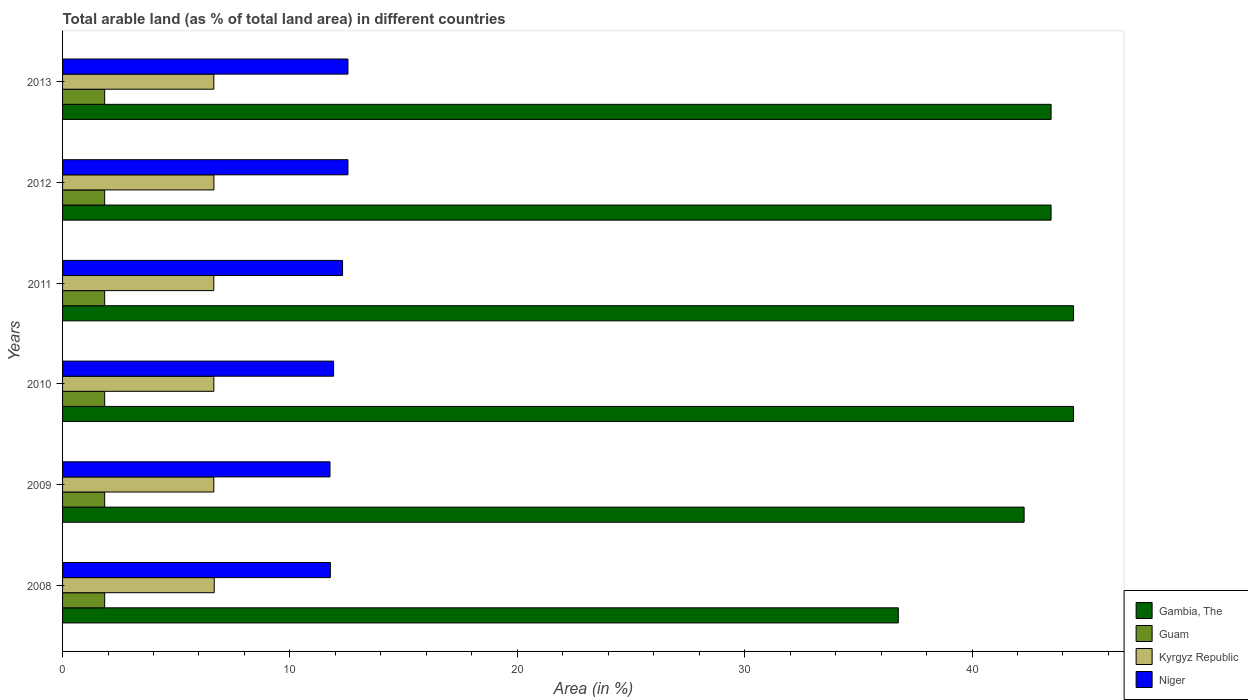How many different coloured bars are there?
Your answer should be very brief. 4. Are the number of bars on each tick of the Y-axis equal?
Offer a terse response. Yes. How many bars are there on the 6th tick from the top?
Offer a terse response. 4. In how many cases, is the number of bars for a given year not equal to the number of legend labels?
Ensure brevity in your answer.  0. What is the percentage of arable land in Gambia, The in 2008?
Keep it short and to the point. 36.76. Across all years, what is the maximum percentage of arable land in Niger?
Make the answer very short. 12.55. Across all years, what is the minimum percentage of arable land in Kyrgyz Republic?
Your response must be concise. 6.65. In which year was the percentage of arable land in Guam minimum?
Provide a short and direct response. 2008. What is the total percentage of arable land in Kyrgyz Republic in the graph?
Ensure brevity in your answer.  39.94. What is the difference between the percentage of arable land in Gambia, The in 2008 and that in 2010?
Offer a very short reply. -7.71. What is the difference between the percentage of arable land in Kyrgyz Republic in 2008 and the percentage of arable land in Niger in 2013?
Offer a terse response. -5.88. What is the average percentage of arable land in Kyrgyz Republic per year?
Provide a short and direct response. 6.66. In the year 2013, what is the difference between the percentage of arable land in Guam and percentage of arable land in Kyrgyz Republic?
Provide a short and direct response. -4.8. In how many years, is the percentage of arable land in Niger greater than 32 %?
Your answer should be compact. 0. What is the ratio of the percentage of arable land in Gambia, The in 2009 to that in 2011?
Your answer should be very brief. 0.95. Is the percentage of arable land in Niger in 2010 less than that in 2011?
Give a very brief answer. Yes. What is the difference between the highest and the second highest percentage of arable land in Kyrgyz Republic?
Ensure brevity in your answer.  0.02. What is the difference between the highest and the lowest percentage of arable land in Kyrgyz Republic?
Make the answer very short. 0.02. In how many years, is the percentage of arable land in Niger greater than the average percentage of arable land in Niger taken over all years?
Offer a very short reply. 3. What does the 4th bar from the top in 2009 represents?
Provide a short and direct response. Gambia, The. What does the 4th bar from the bottom in 2008 represents?
Your response must be concise. Niger. How many years are there in the graph?
Provide a succinct answer. 6. What is the difference between two consecutive major ticks on the X-axis?
Give a very brief answer. 10. Does the graph contain any zero values?
Provide a short and direct response. No. Does the graph contain grids?
Provide a succinct answer. No. How many legend labels are there?
Give a very brief answer. 4. How are the legend labels stacked?
Your answer should be compact. Vertical. What is the title of the graph?
Your response must be concise. Total arable land (as % of total land area) in different countries. What is the label or title of the X-axis?
Offer a very short reply. Area (in %). What is the label or title of the Y-axis?
Offer a very short reply. Years. What is the Area (in %) of Gambia, The in 2008?
Your answer should be very brief. 36.76. What is the Area (in %) in Guam in 2008?
Your answer should be very brief. 1.85. What is the Area (in %) of Kyrgyz Republic in 2008?
Provide a succinct answer. 6.67. What is the Area (in %) of Niger in 2008?
Keep it short and to the point. 11.78. What is the Area (in %) of Gambia, The in 2009?
Make the answer very short. 42.29. What is the Area (in %) in Guam in 2009?
Ensure brevity in your answer.  1.85. What is the Area (in %) in Kyrgyz Republic in 2009?
Your answer should be compact. 6.65. What is the Area (in %) of Niger in 2009?
Offer a very short reply. 11.76. What is the Area (in %) of Gambia, The in 2010?
Keep it short and to the point. 44.47. What is the Area (in %) of Guam in 2010?
Provide a succinct answer. 1.85. What is the Area (in %) in Kyrgyz Republic in 2010?
Your response must be concise. 6.65. What is the Area (in %) of Niger in 2010?
Ensure brevity in your answer.  11.92. What is the Area (in %) in Gambia, The in 2011?
Your response must be concise. 44.47. What is the Area (in %) in Guam in 2011?
Your answer should be very brief. 1.85. What is the Area (in %) in Kyrgyz Republic in 2011?
Offer a very short reply. 6.65. What is the Area (in %) in Niger in 2011?
Your answer should be very brief. 12.32. What is the Area (in %) in Gambia, The in 2012?
Your answer should be very brief. 43.48. What is the Area (in %) in Guam in 2012?
Keep it short and to the point. 1.85. What is the Area (in %) of Kyrgyz Republic in 2012?
Your answer should be very brief. 6.66. What is the Area (in %) in Niger in 2012?
Keep it short and to the point. 12.55. What is the Area (in %) in Gambia, The in 2013?
Your response must be concise. 43.48. What is the Area (in %) of Guam in 2013?
Your response must be concise. 1.85. What is the Area (in %) of Kyrgyz Republic in 2013?
Keep it short and to the point. 6.65. What is the Area (in %) of Niger in 2013?
Provide a short and direct response. 12.55. Across all years, what is the maximum Area (in %) of Gambia, The?
Provide a short and direct response. 44.47. Across all years, what is the maximum Area (in %) in Guam?
Your response must be concise. 1.85. Across all years, what is the maximum Area (in %) in Kyrgyz Republic?
Provide a short and direct response. 6.67. Across all years, what is the maximum Area (in %) in Niger?
Your answer should be very brief. 12.55. Across all years, what is the minimum Area (in %) in Gambia, The?
Your answer should be very brief. 36.76. Across all years, what is the minimum Area (in %) of Guam?
Provide a short and direct response. 1.85. Across all years, what is the minimum Area (in %) of Kyrgyz Republic?
Your response must be concise. 6.65. Across all years, what is the minimum Area (in %) of Niger?
Your answer should be compact. 11.76. What is the total Area (in %) of Gambia, The in the graph?
Give a very brief answer. 254.94. What is the total Area (in %) in Guam in the graph?
Provide a succinct answer. 11.11. What is the total Area (in %) of Kyrgyz Republic in the graph?
Your answer should be compact. 39.94. What is the total Area (in %) in Niger in the graph?
Keep it short and to the point. 72.88. What is the difference between the Area (in %) of Gambia, The in 2008 and that in 2009?
Keep it short and to the point. -5.53. What is the difference between the Area (in %) in Guam in 2008 and that in 2009?
Offer a terse response. 0. What is the difference between the Area (in %) of Kyrgyz Republic in 2008 and that in 2009?
Offer a terse response. 0.02. What is the difference between the Area (in %) in Niger in 2008 and that in 2009?
Your answer should be very brief. 0.02. What is the difference between the Area (in %) in Gambia, The in 2008 and that in 2010?
Your answer should be very brief. -7.71. What is the difference between the Area (in %) in Kyrgyz Republic in 2008 and that in 2010?
Provide a succinct answer. 0.02. What is the difference between the Area (in %) of Niger in 2008 and that in 2010?
Offer a very short reply. -0.14. What is the difference between the Area (in %) of Gambia, The in 2008 and that in 2011?
Your response must be concise. -7.71. What is the difference between the Area (in %) in Guam in 2008 and that in 2011?
Your response must be concise. 0. What is the difference between the Area (in %) of Kyrgyz Republic in 2008 and that in 2011?
Provide a short and direct response. 0.02. What is the difference between the Area (in %) of Niger in 2008 and that in 2011?
Give a very brief answer. -0.54. What is the difference between the Area (in %) of Gambia, The in 2008 and that in 2012?
Make the answer very short. -6.72. What is the difference between the Area (in %) of Kyrgyz Republic in 2008 and that in 2012?
Provide a succinct answer. 0.02. What is the difference between the Area (in %) of Niger in 2008 and that in 2012?
Provide a short and direct response. -0.77. What is the difference between the Area (in %) in Gambia, The in 2008 and that in 2013?
Your answer should be very brief. -6.72. What is the difference between the Area (in %) of Guam in 2008 and that in 2013?
Provide a short and direct response. 0. What is the difference between the Area (in %) of Kyrgyz Republic in 2008 and that in 2013?
Your answer should be compact. 0.02. What is the difference between the Area (in %) of Niger in 2008 and that in 2013?
Provide a short and direct response. -0.77. What is the difference between the Area (in %) in Gambia, The in 2009 and that in 2010?
Ensure brevity in your answer.  -2.17. What is the difference between the Area (in %) of Guam in 2009 and that in 2010?
Provide a succinct answer. 0. What is the difference between the Area (in %) in Kyrgyz Republic in 2009 and that in 2010?
Ensure brevity in your answer.  -0. What is the difference between the Area (in %) of Niger in 2009 and that in 2010?
Provide a short and direct response. -0.16. What is the difference between the Area (in %) in Gambia, The in 2009 and that in 2011?
Provide a short and direct response. -2.17. What is the difference between the Area (in %) in Guam in 2009 and that in 2011?
Make the answer very short. 0. What is the difference between the Area (in %) of Kyrgyz Republic in 2009 and that in 2011?
Keep it short and to the point. 0. What is the difference between the Area (in %) of Niger in 2009 and that in 2011?
Give a very brief answer. -0.55. What is the difference between the Area (in %) in Gambia, The in 2009 and that in 2012?
Provide a succinct answer. -1.19. What is the difference between the Area (in %) in Kyrgyz Republic in 2009 and that in 2012?
Make the answer very short. -0. What is the difference between the Area (in %) of Niger in 2009 and that in 2012?
Give a very brief answer. -0.79. What is the difference between the Area (in %) in Gambia, The in 2009 and that in 2013?
Offer a terse response. -1.19. What is the difference between the Area (in %) in Guam in 2009 and that in 2013?
Your response must be concise. 0. What is the difference between the Area (in %) of Kyrgyz Republic in 2009 and that in 2013?
Keep it short and to the point. 0. What is the difference between the Area (in %) in Niger in 2009 and that in 2013?
Your answer should be compact. -0.79. What is the difference between the Area (in %) of Guam in 2010 and that in 2011?
Make the answer very short. 0. What is the difference between the Area (in %) of Kyrgyz Republic in 2010 and that in 2011?
Your response must be concise. 0. What is the difference between the Area (in %) of Niger in 2010 and that in 2011?
Keep it short and to the point. -0.39. What is the difference between the Area (in %) of Guam in 2010 and that in 2012?
Ensure brevity in your answer.  0. What is the difference between the Area (in %) of Kyrgyz Republic in 2010 and that in 2012?
Ensure brevity in your answer.  -0. What is the difference between the Area (in %) in Niger in 2010 and that in 2012?
Provide a succinct answer. -0.63. What is the difference between the Area (in %) of Gambia, The in 2010 and that in 2013?
Your response must be concise. 0.99. What is the difference between the Area (in %) of Kyrgyz Republic in 2010 and that in 2013?
Provide a short and direct response. 0. What is the difference between the Area (in %) of Niger in 2010 and that in 2013?
Provide a short and direct response. -0.63. What is the difference between the Area (in %) of Gambia, The in 2011 and that in 2012?
Keep it short and to the point. 0.99. What is the difference between the Area (in %) of Kyrgyz Republic in 2011 and that in 2012?
Offer a very short reply. -0. What is the difference between the Area (in %) in Niger in 2011 and that in 2012?
Your answer should be very brief. -0.24. What is the difference between the Area (in %) of Gambia, The in 2011 and that in 2013?
Offer a terse response. 0.99. What is the difference between the Area (in %) of Kyrgyz Republic in 2011 and that in 2013?
Your response must be concise. -0. What is the difference between the Area (in %) in Niger in 2011 and that in 2013?
Offer a very short reply. -0.24. What is the difference between the Area (in %) in Gambia, The in 2012 and that in 2013?
Keep it short and to the point. 0. What is the difference between the Area (in %) of Guam in 2012 and that in 2013?
Give a very brief answer. 0. What is the difference between the Area (in %) in Kyrgyz Republic in 2012 and that in 2013?
Ensure brevity in your answer.  0. What is the difference between the Area (in %) in Niger in 2012 and that in 2013?
Ensure brevity in your answer.  0. What is the difference between the Area (in %) of Gambia, The in 2008 and the Area (in %) of Guam in 2009?
Offer a very short reply. 34.91. What is the difference between the Area (in %) in Gambia, The in 2008 and the Area (in %) in Kyrgyz Republic in 2009?
Your answer should be compact. 30.11. What is the difference between the Area (in %) of Gambia, The in 2008 and the Area (in %) of Niger in 2009?
Keep it short and to the point. 25. What is the difference between the Area (in %) in Guam in 2008 and the Area (in %) in Kyrgyz Republic in 2009?
Your answer should be compact. -4.8. What is the difference between the Area (in %) in Guam in 2008 and the Area (in %) in Niger in 2009?
Provide a succinct answer. -9.91. What is the difference between the Area (in %) of Kyrgyz Republic in 2008 and the Area (in %) of Niger in 2009?
Make the answer very short. -5.09. What is the difference between the Area (in %) of Gambia, The in 2008 and the Area (in %) of Guam in 2010?
Offer a terse response. 34.91. What is the difference between the Area (in %) of Gambia, The in 2008 and the Area (in %) of Kyrgyz Republic in 2010?
Your answer should be very brief. 30.11. What is the difference between the Area (in %) of Gambia, The in 2008 and the Area (in %) of Niger in 2010?
Your answer should be very brief. 24.84. What is the difference between the Area (in %) of Guam in 2008 and the Area (in %) of Kyrgyz Republic in 2010?
Give a very brief answer. -4.8. What is the difference between the Area (in %) of Guam in 2008 and the Area (in %) of Niger in 2010?
Provide a short and direct response. -10.07. What is the difference between the Area (in %) of Kyrgyz Republic in 2008 and the Area (in %) of Niger in 2010?
Provide a short and direct response. -5.25. What is the difference between the Area (in %) in Gambia, The in 2008 and the Area (in %) in Guam in 2011?
Keep it short and to the point. 34.91. What is the difference between the Area (in %) of Gambia, The in 2008 and the Area (in %) of Kyrgyz Republic in 2011?
Your response must be concise. 30.11. What is the difference between the Area (in %) in Gambia, The in 2008 and the Area (in %) in Niger in 2011?
Your response must be concise. 24.44. What is the difference between the Area (in %) of Guam in 2008 and the Area (in %) of Kyrgyz Republic in 2011?
Offer a terse response. -4.8. What is the difference between the Area (in %) in Guam in 2008 and the Area (in %) in Niger in 2011?
Make the answer very short. -10.46. What is the difference between the Area (in %) of Kyrgyz Republic in 2008 and the Area (in %) of Niger in 2011?
Ensure brevity in your answer.  -5.64. What is the difference between the Area (in %) of Gambia, The in 2008 and the Area (in %) of Guam in 2012?
Make the answer very short. 34.91. What is the difference between the Area (in %) of Gambia, The in 2008 and the Area (in %) of Kyrgyz Republic in 2012?
Offer a very short reply. 30.1. What is the difference between the Area (in %) in Gambia, The in 2008 and the Area (in %) in Niger in 2012?
Provide a short and direct response. 24.21. What is the difference between the Area (in %) in Guam in 2008 and the Area (in %) in Kyrgyz Republic in 2012?
Your response must be concise. -4.8. What is the difference between the Area (in %) in Guam in 2008 and the Area (in %) in Niger in 2012?
Make the answer very short. -10.7. What is the difference between the Area (in %) in Kyrgyz Republic in 2008 and the Area (in %) in Niger in 2012?
Keep it short and to the point. -5.88. What is the difference between the Area (in %) of Gambia, The in 2008 and the Area (in %) of Guam in 2013?
Give a very brief answer. 34.91. What is the difference between the Area (in %) of Gambia, The in 2008 and the Area (in %) of Kyrgyz Republic in 2013?
Your response must be concise. 30.11. What is the difference between the Area (in %) of Gambia, The in 2008 and the Area (in %) of Niger in 2013?
Provide a short and direct response. 24.21. What is the difference between the Area (in %) in Guam in 2008 and the Area (in %) in Kyrgyz Republic in 2013?
Provide a short and direct response. -4.8. What is the difference between the Area (in %) in Guam in 2008 and the Area (in %) in Niger in 2013?
Ensure brevity in your answer.  -10.7. What is the difference between the Area (in %) in Kyrgyz Republic in 2008 and the Area (in %) in Niger in 2013?
Provide a succinct answer. -5.88. What is the difference between the Area (in %) of Gambia, The in 2009 and the Area (in %) of Guam in 2010?
Keep it short and to the point. 40.44. What is the difference between the Area (in %) in Gambia, The in 2009 and the Area (in %) in Kyrgyz Republic in 2010?
Your answer should be compact. 35.64. What is the difference between the Area (in %) of Gambia, The in 2009 and the Area (in %) of Niger in 2010?
Ensure brevity in your answer.  30.37. What is the difference between the Area (in %) of Guam in 2009 and the Area (in %) of Kyrgyz Republic in 2010?
Give a very brief answer. -4.8. What is the difference between the Area (in %) in Guam in 2009 and the Area (in %) in Niger in 2010?
Offer a very short reply. -10.07. What is the difference between the Area (in %) in Kyrgyz Republic in 2009 and the Area (in %) in Niger in 2010?
Your answer should be very brief. -5.27. What is the difference between the Area (in %) of Gambia, The in 2009 and the Area (in %) of Guam in 2011?
Provide a short and direct response. 40.44. What is the difference between the Area (in %) of Gambia, The in 2009 and the Area (in %) of Kyrgyz Republic in 2011?
Provide a succinct answer. 35.64. What is the difference between the Area (in %) in Gambia, The in 2009 and the Area (in %) in Niger in 2011?
Provide a succinct answer. 29.98. What is the difference between the Area (in %) of Guam in 2009 and the Area (in %) of Kyrgyz Republic in 2011?
Make the answer very short. -4.8. What is the difference between the Area (in %) of Guam in 2009 and the Area (in %) of Niger in 2011?
Ensure brevity in your answer.  -10.46. What is the difference between the Area (in %) of Kyrgyz Republic in 2009 and the Area (in %) of Niger in 2011?
Give a very brief answer. -5.66. What is the difference between the Area (in %) of Gambia, The in 2009 and the Area (in %) of Guam in 2012?
Provide a short and direct response. 40.44. What is the difference between the Area (in %) in Gambia, The in 2009 and the Area (in %) in Kyrgyz Republic in 2012?
Give a very brief answer. 35.64. What is the difference between the Area (in %) of Gambia, The in 2009 and the Area (in %) of Niger in 2012?
Offer a terse response. 29.74. What is the difference between the Area (in %) in Guam in 2009 and the Area (in %) in Kyrgyz Republic in 2012?
Give a very brief answer. -4.8. What is the difference between the Area (in %) in Guam in 2009 and the Area (in %) in Niger in 2012?
Offer a very short reply. -10.7. What is the difference between the Area (in %) in Kyrgyz Republic in 2009 and the Area (in %) in Niger in 2012?
Provide a succinct answer. -5.9. What is the difference between the Area (in %) of Gambia, The in 2009 and the Area (in %) of Guam in 2013?
Give a very brief answer. 40.44. What is the difference between the Area (in %) of Gambia, The in 2009 and the Area (in %) of Kyrgyz Republic in 2013?
Offer a very short reply. 35.64. What is the difference between the Area (in %) in Gambia, The in 2009 and the Area (in %) in Niger in 2013?
Provide a short and direct response. 29.74. What is the difference between the Area (in %) of Guam in 2009 and the Area (in %) of Kyrgyz Republic in 2013?
Keep it short and to the point. -4.8. What is the difference between the Area (in %) in Guam in 2009 and the Area (in %) in Niger in 2013?
Provide a short and direct response. -10.7. What is the difference between the Area (in %) in Kyrgyz Republic in 2009 and the Area (in %) in Niger in 2013?
Provide a short and direct response. -5.9. What is the difference between the Area (in %) of Gambia, The in 2010 and the Area (in %) of Guam in 2011?
Make the answer very short. 42.61. What is the difference between the Area (in %) in Gambia, The in 2010 and the Area (in %) in Kyrgyz Republic in 2011?
Your answer should be very brief. 37.81. What is the difference between the Area (in %) in Gambia, The in 2010 and the Area (in %) in Niger in 2011?
Make the answer very short. 32.15. What is the difference between the Area (in %) in Guam in 2010 and the Area (in %) in Kyrgyz Republic in 2011?
Your response must be concise. -4.8. What is the difference between the Area (in %) in Guam in 2010 and the Area (in %) in Niger in 2011?
Your response must be concise. -10.46. What is the difference between the Area (in %) of Kyrgyz Republic in 2010 and the Area (in %) of Niger in 2011?
Make the answer very short. -5.66. What is the difference between the Area (in %) in Gambia, The in 2010 and the Area (in %) in Guam in 2012?
Keep it short and to the point. 42.61. What is the difference between the Area (in %) of Gambia, The in 2010 and the Area (in %) of Kyrgyz Republic in 2012?
Provide a short and direct response. 37.81. What is the difference between the Area (in %) of Gambia, The in 2010 and the Area (in %) of Niger in 2012?
Offer a very short reply. 31.91. What is the difference between the Area (in %) in Guam in 2010 and the Area (in %) in Kyrgyz Republic in 2012?
Keep it short and to the point. -4.8. What is the difference between the Area (in %) in Guam in 2010 and the Area (in %) in Niger in 2012?
Provide a succinct answer. -10.7. What is the difference between the Area (in %) of Kyrgyz Republic in 2010 and the Area (in %) of Niger in 2012?
Make the answer very short. -5.9. What is the difference between the Area (in %) of Gambia, The in 2010 and the Area (in %) of Guam in 2013?
Make the answer very short. 42.61. What is the difference between the Area (in %) in Gambia, The in 2010 and the Area (in %) in Kyrgyz Republic in 2013?
Ensure brevity in your answer.  37.81. What is the difference between the Area (in %) in Gambia, The in 2010 and the Area (in %) in Niger in 2013?
Keep it short and to the point. 31.91. What is the difference between the Area (in %) in Guam in 2010 and the Area (in %) in Kyrgyz Republic in 2013?
Ensure brevity in your answer.  -4.8. What is the difference between the Area (in %) in Guam in 2010 and the Area (in %) in Niger in 2013?
Ensure brevity in your answer.  -10.7. What is the difference between the Area (in %) of Kyrgyz Republic in 2010 and the Area (in %) of Niger in 2013?
Ensure brevity in your answer.  -5.9. What is the difference between the Area (in %) of Gambia, The in 2011 and the Area (in %) of Guam in 2012?
Provide a succinct answer. 42.61. What is the difference between the Area (in %) in Gambia, The in 2011 and the Area (in %) in Kyrgyz Republic in 2012?
Give a very brief answer. 37.81. What is the difference between the Area (in %) in Gambia, The in 2011 and the Area (in %) in Niger in 2012?
Your answer should be compact. 31.91. What is the difference between the Area (in %) in Guam in 2011 and the Area (in %) in Kyrgyz Republic in 2012?
Provide a short and direct response. -4.8. What is the difference between the Area (in %) in Guam in 2011 and the Area (in %) in Niger in 2012?
Keep it short and to the point. -10.7. What is the difference between the Area (in %) of Kyrgyz Republic in 2011 and the Area (in %) of Niger in 2012?
Offer a terse response. -5.9. What is the difference between the Area (in %) of Gambia, The in 2011 and the Area (in %) of Guam in 2013?
Your answer should be very brief. 42.61. What is the difference between the Area (in %) in Gambia, The in 2011 and the Area (in %) in Kyrgyz Republic in 2013?
Offer a very short reply. 37.81. What is the difference between the Area (in %) of Gambia, The in 2011 and the Area (in %) of Niger in 2013?
Offer a terse response. 31.91. What is the difference between the Area (in %) of Guam in 2011 and the Area (in %) of Kyrgyz Republic in 2013?
Give a very brief answer. -4.8. What is the difference between the Area (in %) of Guam in 2011 and the Area (in %) of Niger in 2013?
Give a very brief answer. -10.7. What is the difference between the Area (in %) of Kyrgyz Republic in 2011 and the Area (in %) of Niger in 2013?
Ensure brevity in your answer.  -5.9. What is the difference between the Area (in %) of Gambia, The in 2012 and the Area (in %) of Guam in 2013?
Provide a short and direct response. 41.63. What is the difference between the Area (in %) in Gambia, The in 2012 and the Area (in %) in Kyrgyz Republic in 2013?
Offer a terse response. 36.83. What is the difference between the Area (in %) in Gambia, The in 2012 and the Area (in %) in Niger in 2013?
Make the answer very short. 30.93. What is the difference between the Area (in %) in Guam in 2012 and the Area (in %) in Kyrgyz Republic in 2013?
Offer a terse response. -4.8. What is the difference between the Area (in %) in Guam in 2012 and the Area (in %) in Niger in 2013?
Provide a succinct answer. -10.7. What is the difference between the Area (in %) in Kyrgyz Republic in 2012 and the Area (in %) in Niger in 2013?
Make the answer very short. -5.9. What is the average Area (in %) of Gambia, The per year?
Give a very brief answer. 42.49. What is the average Area (in %) of Guam per year?
Your answer should be very brief. 1.85. What is the average Area (in %) of Kyrgyz Republic per year?
Provide a short and direct response. 6.66. What is the average Area (in %) of Niger per year?
Provide a short and direct response. 12.15. In the year 2008, what is the difference between the Area (in %) in Gambia, The and Area (in %) in Guam?
Keep it short and to the point. 34.91. In the year 2008, what is the difference between the Area (in %) of Gambia, The and Area (in %) of Kyrgyz Republic?
Give a very brief answer. 30.09. In the year 2008, what is the difference between the Area (in %) of Gambia, The and Area (in %) of Niger?
Provide a short and direct response. 24.98. In the year 2008, what is the difference between the Area (in %) in Guam and Area (in %) in Kyrgyz Republic?
Make the answer very short. -4.82. In the year 2008, what is the difference between the Area (in %) of Guam and Area (in %) of Niger?
Provide a succinct answer. -9.93. In the year 2008, what is the difference between the Area (in %) of Kyrgyz Republic and Area (in %) of Niger?
Make the answer very short. -5.11. In the year 2009, what is the difference between the Area (in %) of Gambia, The and Area (in %) of Guam?
Keep it short and to the point. 40.44. In the year 2009, what is the difference between the Area (in %) of Gambia, The and Area (in %) of Kyrgyz Republic?
Provide a short and direct response. 35.64. In the year 2009, what is the difference between the Area (in %) in Gambia, The and Area (in %) in Niger?
Offer a terse response. 30.53. In the year 2009, what is the difference between the Area (in %) of Guam and Area (in %) of Kyrgyz Republic?
Your answer should be compact. -4.8. In the year 2009, what is the difference between the Area (in %) of Guam and Area (in %) of Niger?
Your response must be concise. -9.91. In the year 2009, what is the difference between the Area (in %) in Kyrgyz Republic and Area (in %) in Niger?
Provide a short and direct response. -5.11. In the year 2010, what is the difference between the Area (in %) in Gambia, The and Area (in %) in Guam?
Provide a short and direct response. 42.61. In the year 2010, what is the difference between the Area (in %) in Gambia, The and Area (in %) in Kyrgyz Republic?
Provide a succinct answer. 37.81. In the year 2010, what is the difference between the Area (in %) of Gambia, The and Area (in %) of Niger?
Keep it short and to the point. 32.55. In the year 2010, what is the difference between the Area (in %) of Guam and Area (in %) of Kyrgyz Republic?
Offer a very short reply. -4.8. In the year 2010, what is the difference between the Area (in %) in Guam and Area (in %) in Niger?
Your answer should be compact. -10.07. In the year 2010, what is the difference between the Area (in %) in Kyrgyz Republic and Area (in %) in Niger?
Your answer should be very brief. -5.27. In the year 2011, what is the difference between the Area (in %) in Gambia, The and Area (in %) in Guam?
Your response must be concise. 42.61. In the year 2011, what is the difference between the Area (in %) of Gambia, The and Area (in %) of Kyrgyz Republic?
Offer a very short reply. 37.81. In the year 2011, what is the difference between the Area (in %) in Gambia, The and Area (in %) in Niger?
Ensure brevity in your answer.  32.15. In the year 2011, what is the difference between the Area (in %) of Guam and Area (in %) of Kyrgyz Republic?
Ensure brevity in your answer.  -4.8. In the year 2011, what is the difference between the Area (in %) of Guam and Area (in %) of Niger?
Offer a terse response. -10.46. In the year 2011, what is the difference between the Area (in %) of Kyrgyz Republic and Area (in %) of Niger?
Provide a short and direct response. -5.66. In the year 2012, what is the difference between the Area (in %) in Gambia, The and Area (in %) in Guam?
Give a very brief answer. 41.63. In the year 2012, what is the difference between the Area (in %) in Gambia, The and Area (in %) in Kyrgyz Republic?
Offer a very short reply. 36.82. In the year 2012, what is the difference between the Area (in %) in Gambia, The and Area (in %) in Niger?
Your response must be concise. 30.93. In the year 2012, what is the difference between the Area (in %) in Guam and Area (in %) in Kyrgyz Republic?
Offer a terse response. -4.8. In the year 2012, what is the difference between the Area (in %) of Guam and Area (in %) of Niger?
Your answer should be compact. -10.7. In the year 2012, what is the difference between the Area (in %) in Kyrgyz Republic and Area (in %) in Niger?
Keep it short and to the point. -5.9. In the year 2013, what is the difference between the Area (in %) in Gambia, The and Area (in %) in Guam?
Provide a succinct answer. 41.63. In the year 2013, what is the difference between the Area (in %) in Gambia, The and Area (in %) in Kyrgyz Republic?
Provide a succinct answer. 36.83. In the year 2013, what is the difference between the Area (in %) of Gambia, The and Area (in %) of Niger?
Offer a terse response. 30.93. In the year 2013, what is the difference between the Area (in %) of Guam and Area (in %) of Kyrgyz Republic?
Provide a short and direct response. -4.8. In the year 2013, what is the difference between the Area (in %) in Guam and Area (in %) in Niger?
Your answer should be compact. -10.7. In the year 2013, what is the difference between the Area (in %) of Kyrgyz Republic and Area (in %) of Niger?
Ensure brevity in your answer.  -5.9. What is the ratio of the Area (in %) of Gambia, The in 2008 to that in 2009?
Offer a terse response. 0.87. What is the ratio of the Area (in %) of Guam in 2008 to that in 2009?
Make the answer very short. 1. What is the ratio of the Area (in %) of Gambia, The in 2008 to that in 2010?
Your answer should be compact. 0.83. What is the ratio of the Area (in %) in Kyrgyz Republic in 2008 to that in 2010?
Your answer should be compact. 1. What is the ratio of the Area (in %) in Niger in 2008 to that in 2010?
Your response must be concise. 0.99. What is the ratio of the Area (in %) of Gambia, The in 2008 to that in 2011?
Offer a terse response. 0.83. What is the ratio of the Area (in %) of Niger in 2008 to that in 2011?
Ensure brevity in your answer.  0.96. What is the ratio of the Area (in %) in Gambia, The in 2008 to that in 2012?
Keep it short and to the point. 0.85. What is the ratio of the Area (in %) of Guam in 2008 to that in 2012?
Your answer should be very brief. 1. What is the ratio of the Area (in %) of Niger in 2008 to that in 2012?
Your answer should be very brief. 0.94. What is the ratio of the Area (in %) in Gambia, The in 2008 to that in 2013?
Give a very brief answer. 0.85. What is the ratio of the Area (in %) of Guam in 2008 to that in 2013?
Ensure brevity in your answer.  1. What is the ratio of the Area (in %) of Kyrgyz Republic in 2008 to that in 2013?
Give a very brief answer. 1. What is the ratio of the Area (in %) in Niger in 2008 to that in 2013?
Keep it short and to the point. 0.94. What is the ratio of the Area (in %) of Gambia, The in 2009 to that in 2010?
Your response must be concise. 0.95. What is the ratio of the Area (in %) of Niger in 2009 to that in 2010?
Provide a succinct answer. 0.99. What is the ratio of the Area (in %) of Gambia, The in 2009 to that in 2011?
Keep it short and to the point. 0.95. What is the ratio of the Area (in %) of Guam in 2009 to that in 2011?
Your answer should be compact. 1. What is the ratio of the Area (in %) of Kyrgyz Republic in 2009 to that in 2011?
Give a very brief answer. 1. What is the ratio of the Area (in %) of Niger in 2009 to that in 2011?
Give a very brief answer. 0.96. What is the ratio of the Area (in %) of Gambia, The in 2009 to that in 2012?
Your answer should be compact. 0.97. What is the ratio of the Area (in %) in Guam in 2009 to that in 2012?
Your answer should be very brief. 1. What is the ratio of the Area (in %) in Kyrgyz Republic in 2009 to that in 2012?
Provide a short and direct response. 1. What is the ratio of the Area (in %) in Niger in 2009 to that in 2012?
Your response must be concise. 0.94. What is the ratio of the Area (in %) in Gambia, The in 2009 to that in 2013?
Your answer should be very brief. 0.97. What is the ratio of the Area (in %) of Guam in 2009 to that in 2013?
Make the answer very short. 1. What is the ratio of the Area (in %) of Kyrgyz Republic in 2009 to that in 2013?
Your answer should be very brief. 1. What is the ratio of the Area (in %) of Niger in 2009 to that in 2013?
Keep it short and to the point. 0.94. What is the ratio of the Area (in %) of Gambia, The in 2010 to that in 2011?
Your answer should be very brief. 1. What is the ratio of the Area (in %) of Guam in 2010 to that in 2011?
Provide a short and direct response. 1. What is the ratio of the Area (in %) of Kyrgyz Republic in 2010 to that in 2011?
Ensure brevity in your answer.  1. What is the ratio of the Area (in %) in Niger in 2010 to that in 2011?
Your answer should be compact. 0.97. What is the ratio of the Area (in %) of Gambia, The in 2010 to that in 2012?
Provide a succinct answer. 1.02. What is the ratio of the Area (in %) in Niger in 2010 to that in 2012?
Make the answer very short. 0.95. What is the ratio of the Area (in %) in Gambia, The in 2010 to that in 2013?
Your answer should be very brief. 1.02. What is the ratio of the Area (in %) of Guam in 2010 to that in 2013?
Ensure brevity in your answer.  1. What is the ratio of the Area (in %) in Kyrgyz Republic in 2010 to that in 2013?
Provide a succinct answer. 1. What is the ratio of the Area (in %) of Niger in 2010 to that in 2013?
Offer a terse response. 0.95. What is the ratio of the Area (in %) in Gambia, The in 2011 to that in 2012?
Keep it short and to the point. 1.02. What is the ratio of the Area (in %) of Kyrgyz Republic in 2011 to that in 2012?
Offer a very short reply. 1. What is the ratio of the Area (in %) in Niger in 2011 to that in 2012?
Your answer should be very brief. 0.98. What is the ratio of the Area (in %) of Gambia, The in 2011 to that in 2013?
Keep it short and to the point. 1.02. What is the ratio of the Area (in %) of Kyrgyz Republic in 2011 to that in 2013?
Provide a succinct answer. 1. What is the ratio of the Area (in %) in Niger in 2011 to that in 2013?
Provide a short and direct response. 0.98. What is the ratio of the Area (in %) in Guam in 2012 to that in 2013?
Your answer should be compact. 1. What is the ratio of the Area (in %) in Kyrgyz Republic in 2012 to that in 2013?
Provide a short and direct response. 1. What is the ratio of the Area (in %) of Niger in 2012 to that in 2013?
Offer a terse response. 1. What is the difference between the highest and the second highest Area (in %) of Gambia, The?
Provide a succinct answer. 0. What is the difference between the highest and the second highest Area (in %) in Guam?
Offer a very short reply. 0. What is the difference between the highest and the second highest Area (in %) of Kyrgyz Republic?
Provide a short and direct response. 0.02. What is the difference between the highest and the second highest Area (in %) of Niger?
Your answer should be compact. 0. What is the difference between the highest and the lowest Area (in %) in Gambia, The?
Ensure brevity in your answer.  7.71. What is the difference between the highest and the lowest Area (in %) in Kyrgyz Republic?
Ensure brevity in your answer.  0.02. What is the difference between the highest and the lowest Area (in %) of Niger?
Your response must be concise. 0.79. 